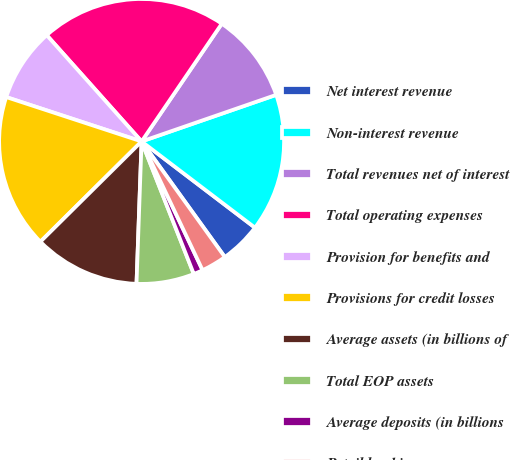<chart> <loc_0><loc_0><loc_500><loc_500><pie_chart><fcel>Net interest revenue<fcel>Non-interest revenue<fcel>Total revenues net of interest<fcel>Total operating expenses<fcel>Provision for benefits and<fcel>Provisions for credit losses<fcel>Average assets (in billions of<fcel>Total EOP assets<fcel>Average deposits (in billions<fcel>Retail banking<nl><fcel>4.72%<fcel>15.65%<fcel>10.18%<fcel>21.11%<fcel>8.36%<fcel>17.47%<fcel>12.0%<fcel>6.54%<fcel>1.07%<fcel>2.89%<nl></chart> 